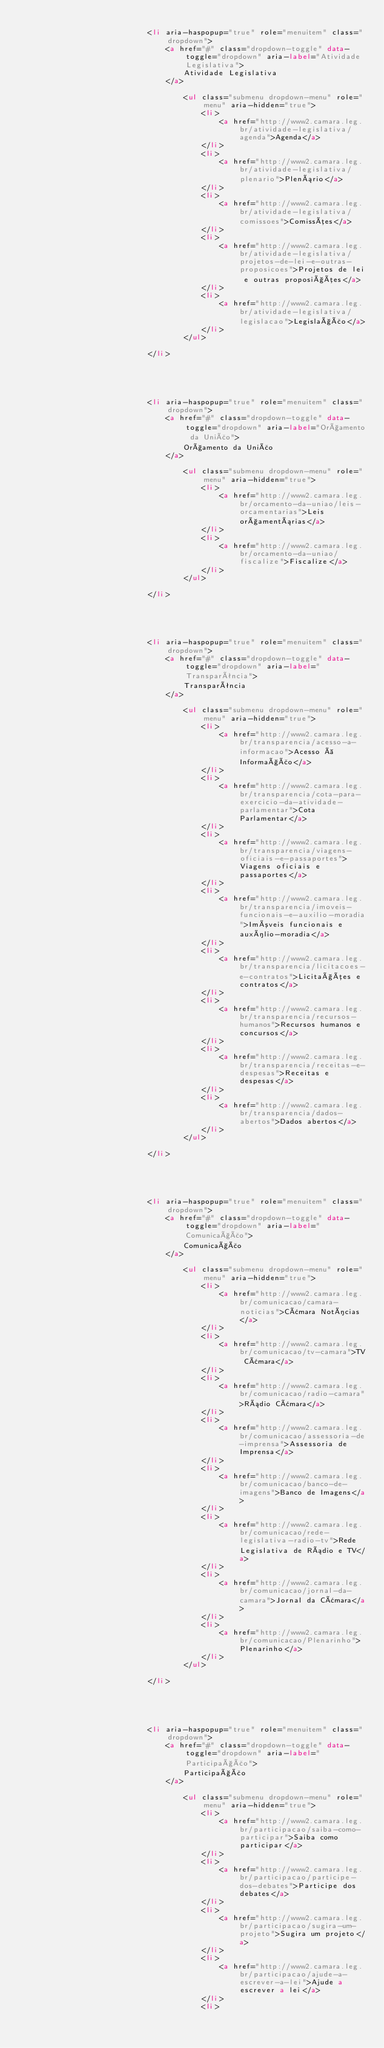Convert code to text. <code><loc_0><loc_0><loc_500><loc_500><_HTML_>                            
                            <li aria-haspopup="true" role="menuitem" class="dropdown">
                                <a href="#" class="dropdown-toggle" data-toggle="dropdown" aria-label="Atividade Legislativa">
                                    Atividade Legislativa
                                </a>
                                
                                    <ul class="submenu dropdown-menu" role="menu" aria-hidden="true">
                                        <li>
                                            <a href="http://www2.camara.leg.br/atividade-legislativa/agenda">Agenda</a>
                                        </li>
                                        <li>
                                            <a href="http://www2.camara.leg.br/atividade-legislativa/plenario">Plenário</a>
                                        </li>
                                        <li>
                                            <a href="http://www2.camara.leg.br/atividade-legislativa/comissoes">Comissões</a>
                                        </li>
                                        <li>
                                            <a href="http://www2.camara.leg.br/atividade-legislativa/projetos-de-lei-e-outras-proposicoes">Projetos de lei e outras proposições</a>
                                        </li>
                                        <li>
                                            <a href="http://www2.camara.leg.br/atividade-legislativa/legislacao">Legislação</a>
                                        </li>
                                    </ul>
                                
                            </li>
                        
                    
                    
                        
                            
                            <li aria-haspopup="true" role="menuitem" class="dropdown">
                                <a href="#" class="dropdown-toggle" data-toggle="dropdown" aria-label="Orçamento da União">
                                    Orçamento da União
                                </a>
                                
                                    <ul class="submenu dropdown-menu" role="menu" aria-hidden="true">
                                        <li>
                                            <a href="http://www2.camara.leg.br/orcamento-da-uniao/leis-orcamentarias">Leis orçamentárias</a>
                                        </li>
                                        <li>
                                            <a href="http://www2.camara.leg.br/orcamento-da-uniao/fiscalize">Fiscalize</a>
                                        </li>
                                    </ul>
                                
                            </li>
                        
                    
                    
                        
                            
                            <li aria-haspopup="true" role="menuitem" class="dropdown">
                                <a href="#" class="dropdown-toggle" data-toggle="dropdown" aria-label="Transparência">
                                    Transparência
                                </a>
                                
                                    <ul class="submenu dropdown-menu" role="menu" aria-hidden="true">
                                        <li>
                                            <a href="http://www2.camara.leg.br/transparencia/acesso-a-informacao">Acesso à Informação</a>
                                        </li>
                                        <li>
                                            <a href="http://www2.camara.leg.br/transparencia/cota-para-exercicio-da-atividade-parlamentar">Cota Parlamentar</a>
                                        </li>
                                        <li>
                                            <a href="http://www2.camara.leg.br/transparencia/viagens-oficiais-e-passaportes">Viagens oficiais e passaportes</a>
                                        </li>
                                        <li>
                                            <a href="http://www2.camara.leg.br/transparencia/imoveis-funcionais-e-auxilio-moradia">Imóveis funcionais e auxílio-moradia</a>
                                        </li>
                                        <li>
                                            <a href="http://www2.camara.leg.br/transparencia/licitacoes-e-contratos">Licitações e contratos</a>
                                        </li>
                                        <li>
                                            <a href="http://www2.camara.leg.br/transparencia/recursos-humanos">Recursos humanos e concursos</a>
                                        </li>
                                        <li>
                                            <a href="http://www2.camara.leg.br/transparencia/receitas-e-despesas">Receitas e despesas</a>
                                        </li>
                                        <li>
                                            <a href="http://www2.camara.leg.br/transparencia/dados-abertos">Dados abertos</a>
                                        </li>
                                    </ul>
                                
                            </li>
                        
                    
                    
                        
                            
                            <li aria-haspopup="true" role="menuitem" class="dropdown">
                                <a href="#" class="dropdown-toggle" data-toggle="dropdown" aria-label="Comunicação">
                                    Comunicação
                                </a>
                                
                                    <ul class="submenu dropdown-menu" role="menu" aria-hidden="true">
                                        <li>
                                            <a href="http://www2.camara.leg.br/comunicacao/camara-noticias">Câmara Notícias</a>
                                        </li>
                                        <li>
                                            <a href="http://www2.camara.leg.br/comunicacao/tv-camara">TV Câmara</a>
                                        </li>
                                        <li>
                                            <a href="http://www2.camara.leg.br/comunicacao/radio-camara">Rádio Câmara</a>
                                        </li>
                                        <li>
                                            <a href="http://www2.camara.leg.br/comunicacao/assessoria-de-imprensa">Assessoria de Imprensa</a>
                                        </li>
                                        <li>
                                            <a href="http://www2.camara.leg.br/comunicacao/banco-de-imagens">Banco de Imagens</a>
                                        </li>
                                        <li>
                                            <a href="http://www2.camara.leg.br/comunicacao/rede-legislativa-radio-tv">Rede Legislativa de Rádio e TV</a>
                                        </li>
                                        <li>
                                            <a href="http://www2.camara.leg.br/comunicacao/jornal-da-camara">Jornal da Câmara</a>
                                        </li>
                                        <li>
                                            <a href="http://www2.camara.leg.br/comunicacao/Plenarinho">Plenarinho</a>
                                        </li>
                                    </ul>
                                
                            </li>
                        
                    
                    
                        
                            
                            <li aria-haspopup="true" role="menuitem" class="dropdown">
                                <a href="#" class="dropdown-toggle" data-toggle="dropdown" aria-label="Participação">
                                    Participação
                                </a>
                                
                                    <ul class="submenu dropdown-menu" role="menu" aria-hidden="true">
                                        <li>
                                            <a href="http://www2.camara.leg.br/participacao/saiba-como-participar">Saiba como participar</a>
                                        </li>
                                        <li>
                                            <a href="http://www2.camara.leg.br/participacao/participe-dos-debates">Participe dos debates</a>
                                        </li>
                                        <li>
                                            <a href="http://www2.camara.leg.br/participacao/sugira-um-projeto">Sugira um projeto</a>
                                        </li>
                                        <li>
                                            <a href="http://www2.camara.leg.br/participacao/ajude-a-escrever-a-lei">Ajude a escrever a lei</a>
                                        </li>
                                        <li></code> 